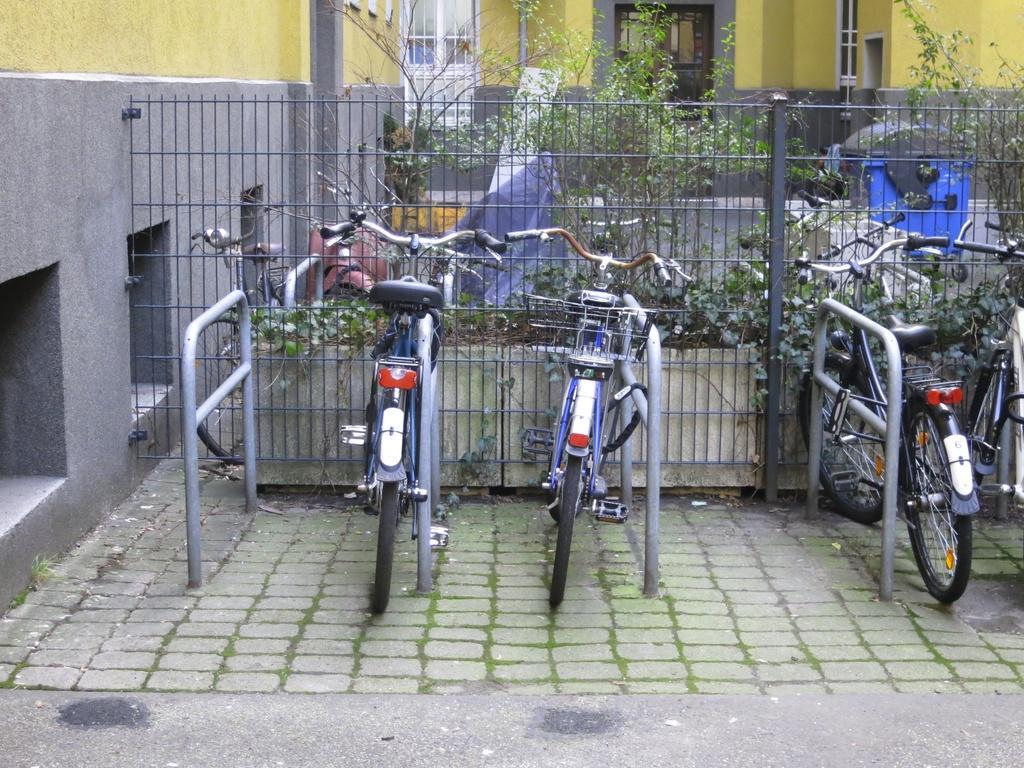Please provide a concise description of this image. In this image we can see bicycles and the barriers. Behind the bicycles we can see the fencing, plants, buildings and a dustbin. On the left side, we can see a wall of a building. 